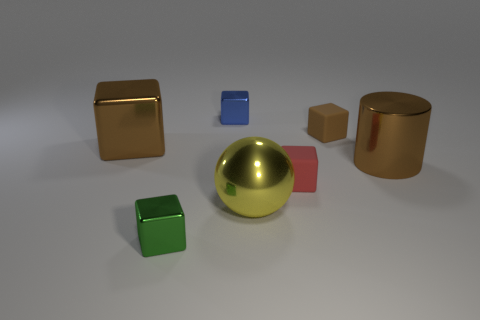Subtract all tiny rubber blocks. How many blocks are left? 3 Add 1 small rubber objects. How many objects exist? 8 Subtract all brown cubes. How many cubes are left? 3 Subtract all cylinders. How many objects are left? 6 Subtract 5 cubes. How many cubes are left? 0 Subtract all brown cylinders. How many blue blocks are left? 1 Subtract 0 cyan cylinders. How many objects are left? 7 Subtract all red cubes. Subtract all brown balls. How many cubes are left? 4 Subtract all tiny brown things. Subtract all brown cylinders. How many objects are left? 5 Add 3 big brown objects. How many big brown objects are left? 5 